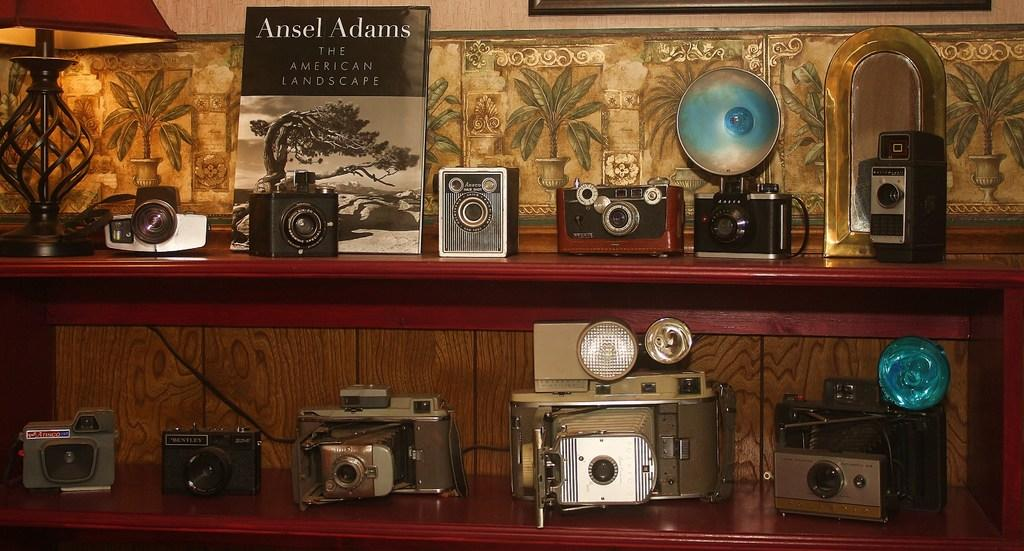Provide a one-sentence caption for the provided image. In addition to the collection of cameras a copy of The American Landscape by Ansel Adams. 